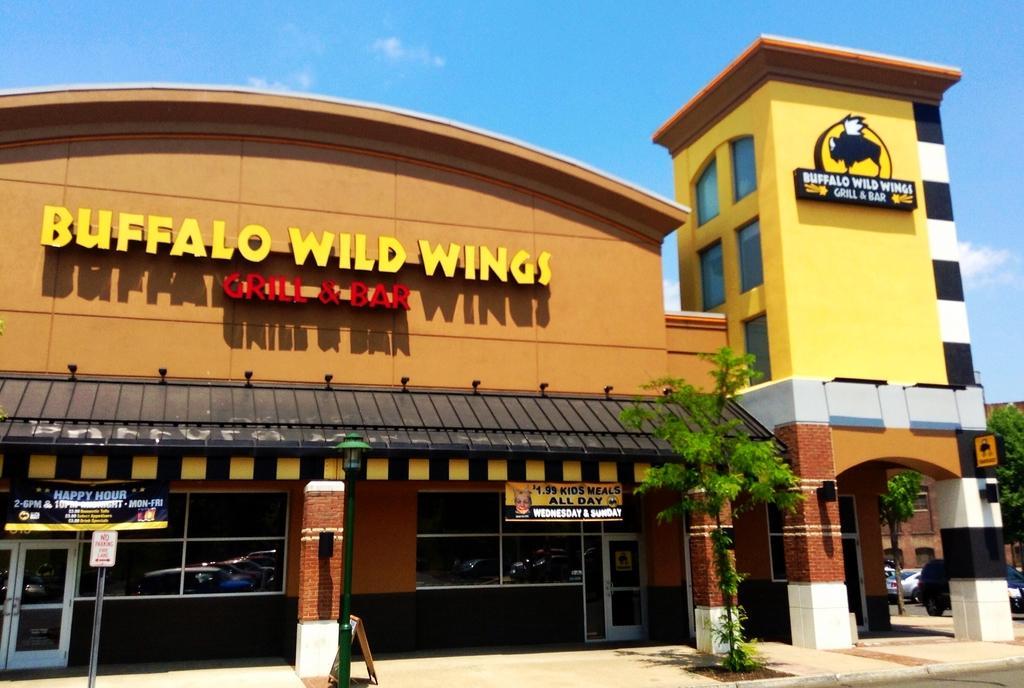Please provide a concise description of this image. In this image I can see plants and trees in green color. Background I can see few stalls and the building is in orange and yellow color. The sky is in blue and white color. 